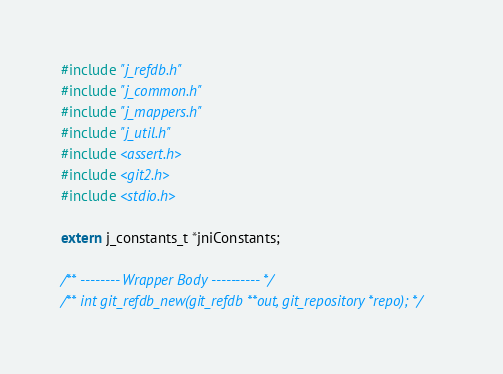<code> <loc_0><loc_0><loc_500><loc_500><_C_>#include "j_refdb.h"
#include "j_common.h"
#include "j_mappers.h"
#include "j_util.h"
#include <assert.h>
#include <git2.h>
#include <stdio.h>

extern j_constants_t *jniConstants;

/** -------- Wrapper Body ---------- */
/** int git_refdb_new(git_refdb **out, git_repository *repo); */</code> 